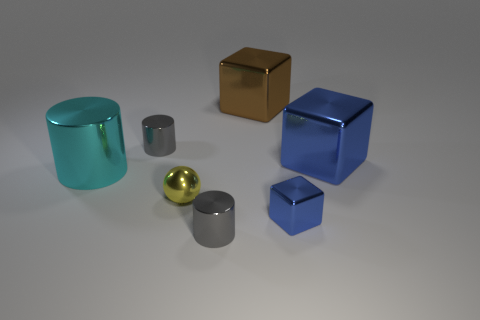What is the shape of the small gray object that is in front of the yellow object?
Make the answer very short. Cylinder. What is the color of the metallic cylinder to the right of the gray cylinder that is behind the large object that is left of the big brown metal object?
Offer a very short reply. Gray. Do the tiny yellow thing and the cyan cylinder have the same material?
Make the answer very short. Yes. How many brown objects are either big metallic cylinders or tiny metal blocks?
Provide a short and direct response. 0. What number of small blue blocks are behind the brown block?
Your response must be concise. 0. Is the number of yellow metallic objects greater than the number of large yellow metallic blocks?
Keep it short and to the point. Yes. The blue object in front of the yellow object left of the big brown metallic cube is what shape?
Ensure brevity in your answer.  Cube. Do the ball and the large metallic cylinder have the same color?
Your response must be concise. No. Is the number of small metal balls behind the brown thing greater than the number of yellow objects?
Keep it short and to the point. No. There is a large metal object on the left side of the big brown shiny thing; how many small yellow shiny balls are in front of it?
Keep it short and to the point. 1. 